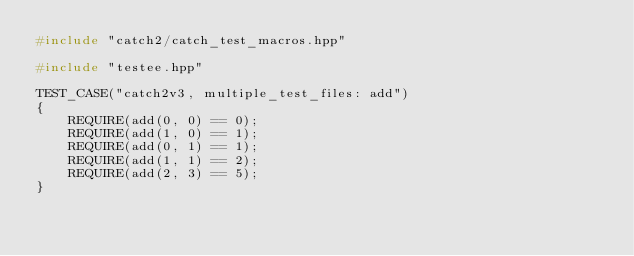Convert code to text. <code><loc_0><loc_0><loc_500><loc_500><_C++_>#include "catch2/catch_test_macros.hpp"

#include "testee.hpp"

TEST_CASE("catch2v3, multiple_test_files: add")
{
    REQUIRE(add(0, 0) == 0);
    REQUIRE(add(1, 0) == 1);
    REQUIRE(add(0, 1) == 1);
    REQUIRE(add(1, 1) == 2);
    REQUIRE(add(2, 3) == 5);
}
</code> 